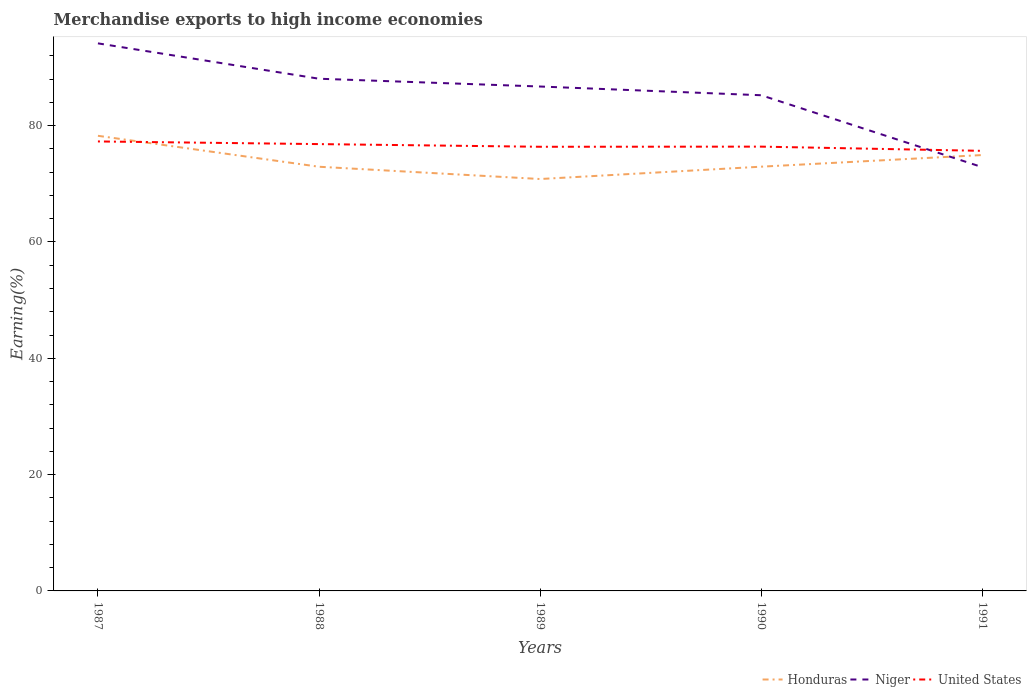Across all years, what is the maximum percentage of amount earned from merchandise exports in Honduras?
Keep it short and to the point. 70.82. What is the total percentage of amount earned from merchandise exports in Niger in the graph?
Make the answer very short. 1.5. What is the difference between the highest and the second highest percentage of amount earned from merchandise exports in Honduras?
Make the answer very short. 7.43. How many lines are there?
Provide a short and direct response. 3. Are the values on the major ticks of Y-axis written in scientific E-notation?
Provide a short and direct response. No. Does the graph contain any zero values?
Ensure brevity in your answer.  No. Does the graph contain grids?
Your answer should be compact. No. Where does the legend appear in the graph?
Keep it short and to the point. Bottom right. How many legend labels are there?
Ensure brevity in your answer.  3. What is the title of the graph?
Make the answer very short. Merchandise exports to high income economies. Does "Slovenia" appear as one of the legend labels in the graph?
Make the answer very short. No. What is the label or title of the X-axis?
Your answer should be very brief. Years. What is the label or title of the Y-axis?
Keep it short and to the point. Earning(%). What is the Earning(%) of Honduras in 1987?
Your answer should be compact. 78.25. What is the Earning(%) of Niger in 1987?
Provide a short and direct response. 94.15. What is the Earning(%) of United States in 1987?
Provide a succinct answer. 77.28. What is the Earning(%) of Honduras in 1988?
Your response must be concise. 72.93. What is the Earning(%) of Niger in 1988?
Give a very brief answer. 88.07. What is the Earning(%) in United States in 1988?
Provide a succinct answer. 76.83. What is the Earning(%) in Honduras in 1989?
Make the answer very short. 70.82. What is the Earning(%) of Niger in 1989?
Your answer should be compact. 86.73. What is the Earning(%) in United States in 1989?
Provide a short and direct response. 76.37. What is the Earning(%) of Honduras in 1990?
Provide a succinct answer. 72.94. What is the Earning(%) of Niger in 1990?
Provide a short and direct response. 85.23. What is the Earning(%) in United States in 1990?
Provide a short and direct response. 76.39. What is the Earning(%) of Honduras in 1991?
Your answer should be very brief. 74.95. What is the Earning(%) of Niger in 1991?
Provide a short and direct response. 72.86. What is the Earning(%) of United States in 1991?
Offer a terse response. 75.67. Across all years, what is the maximum Earning(%) of Honduras?
Keep it short and to the point. 78.25. Across all years, what is the maximum Earning(%) in Niger?
Provide a short and direct response. 94.15. Across all years, what is the maximum Earning(%) of United States?
Your answer should be compact. 77.28. Across all years, what is the minimum Earning(%) of Honduras?
Keep it short and to the point. 70.82. Across all years, what is the minimum Earning(%) in Niger?
Provide a short and direct response. 72.86. Across all years, what is the minimum Earning(%) in United States?
Your answer should be compact. 75.67. What is the total Earning(%) of Honduras in the graph?
Give a very brief answer. 369.9. What is the total Earning(%) of Niger in the graph?
Offer a terse response. 427.03. What is the total Earning(%) of United States in the graph?
Make the answer very short. 382.54. What is the difference between the Earning(%) in Honduras in 1987 and that in 1988?
Your response must be concise. 5.32. What is the difference between the Earning(%) in Niger in 1987 and that in 1988?
Offer a very short reply. 6.08. What is the difference between the Earning(%) of United States in 1987 and that in 1988?
Give a very brief answer. 0.46. What is the difference between the Earning(%) of Honduras in 1987 and that in 1989?
Provide a succinct answer. 7.43. What is the difference between the Earning(%) in Niger in 1987 and that in 1989?
Provide a short and direct response. 7.42. What is the difference between the Earning(%) of United States in 1987 and that in 1989?
Offer a terse response. 0.92. What is the difference between the Earning(%) in Honduras in 1987 and that in 1990?
Offer a terse response. 5.31. What is the difference between the Earning(%) of Niger in 1987 and that in 1990?
Ensure brevity in your answer.  8.92. What is the difference between the Earning(%) of United States in 1987 and that in 1990?
Offer a terse response. 0.89. What is the difference between the Earning(%) of Honduras in 1987 and that in 1991?
Provide a succinct answer. 3.31. What is the difference between the Earning(%) in Niger in 1987 and that in 1991?
Your response must be concise. 21.29. What is the difference between the Earning(%) in United States in 1987 and that in 1991?
Your answer should be compact. 1.62. What is the difference between the Earning(%) in Honduras in 1988 and that in 1989?
Offer a very short reply. 2.11. What is the difference between the Earning(%) of Niger in 1988 and that in 1989?
Offer a very short reply. 1.34. What is the difference between the Earning(%) of United States in 1988 and that in 1989?
Ensure brevity in your answer.  0.46. What is the difference between the Earning(%) of Honduras in 1988 and that in 1990?
Your response must be concise. -0.01. What is the difference between the Earning(%) of Niger in 1988 and that in 1990?
Offer a terse response. 2.84. What is the difference between the Earning(%) in United States in 1988 and that in 1990?
Keep it short and to the point. 0.43. What is the difference between the Earning(%) of Honduras in 1988 and that in 1991?
Give a very brief answer. -2.01. What is the difference between the Earning(%) in Niger in 1988 and that in 1991?
Offer a terse response. 15.2. What is the difference between the Earning(%) in United States in 1988 and that in 1991?
Your answer should be compact. 1.16. What is the difference between the Earning(%) in Honduras in 1989 and that in 1990?
Your answer should be very brief. -2.12. What is the difference between the Earning(%) of Niger in 1989 and that in 1990?
Make the answer very short. 1.5. What is the difference between the Earning(%) of United States in 1989 and that in 1990?
Offer a terse response. -0.02. What is the difference between the Earning(%) in Honduras in 1989 and that in 1991?
Provide a succinct answer. -4.12. What is the difference between the Earning(%) of Niger in 1989 and that in 1991?
Provide a succinct answer. 13.87. What is the difference between the Earning(%) in United States in 1989 and that in 1991?
Provide a succinct answer. 0.7. What is the difference between the Earning(%) of Honduras in 1990 and that in 1991?
Provide a short and direct response. -2. What is the difference between the Earning(%) of Niger in 1990 and that in 1991?
Provide a short and direct response. 12.37. What is the difference between the Earning(%) in United States in 1990 and that in 1991?
Make the answer very short. 0.72. What is the difference between the Earning(%) of Honduras in 1987 and the Earning(%) of Niger in 1988?
Your response must be concise. -9.81. What is the difference between the Earning(%) of Honduras in 1987 and the Earning(%) of United States in 1988?
Your answer should be very brief. 1.43. What is the difference between the Earning(%) of Niger in 1987 and the Earning(%) of United States in 1988?
Keep it short and to the point. 17.32. What is the difference between the Earning(%) of Honduras in 1987 and the Earning(%) of Niger in 1989?
Your response must be concise. -8.47. What is the difference between the Earning(%) of Honduras in 1987 and the Earning(%) of United States in 1989?
Offer a terse response. 1.89. What is the difference between the Earning(%) of Niger in 1987 and the Earning(%) of United States in 1989?
Provide a succinct answer. 17.78. What is the difference between the Earning(%) of Honduras in 1987 and the Earning(%) of Niger in 1990?
Keep it short and to the point. -6.97. What is the difference between the Earning(%) in Honduras in 1987 and the Earning(%) in United States in 1990?
Provide a succinct answer. 1.86. What is the difference between the Earning(%) of Niger in 1987 and the Earning(%) of United States in 1990?
Offer a terse response. 17.76. What is the difference between the Earning(%) in Honduras in 1987 and the Earning(%) in Niger in 1991?
Your answer should be very brief. 5.39. What is the difference between the Earning(%) of Honduras in 1987 and the Earning(%) of United States in 1991?
Your response must be concise. 2.59. What is the difference between the Earning(%) of Niger in 1987 and the Earning(%) of United States in 1991?
Provide a short and direct response. 18.48. What is the difference between the Earning(%) of Honduras in 1988 and the Earning(%) of Niger in 1989?
Offer a terse response. -13.8. What is the difference between the Earning(%) in Honduras in 1988 and the Earning(%) in United States in 1989?
Offer a terse response. -3.43. What is the difference between the Earning(%) in Niger in 1988 and the Earning(%) in United States in 1989?
Make the answer very short. 11.7. What is the difference between the Earning(%) in Honduras in 1988 and the Earning(%) in Niger in 1990?
Offer a very short reply. -12.3. What is the difference between the Earning(%) in Honduras in 1988 and the Earning(%) in United States in 1990?
Provide a short and direct response. -3.46. What is the difference between the Earning(%) in Niger in 1988 and the Earning(%) in United States in 1990?
Your answer should be compact. 11.67. What is the difference between the Earning(%) of Honduras in 1988 and the Earning(%) of Niger in 1991?
Offer a very short reply. 0.07. What is the difference between the Earning(%) in Honduras in 1988 and the Earning(%) in United States in 1991?
Give a very brief answer. -2.73. What is the difference between the Earning(%) in Niger in 1988 and the Earning(%) in United States in 1991?
Offer a terse response. 12.4. What is the difference between the Earning(%) in Honduras in 1989 and the Earning(%) in Niger in 1990?
Your answer should be very brief. -14.4. What is the difference between the Earning(%) of Honduras in 1989 and the Earning(%) of United States in 1990?
Provide a short and direct response. -5.57. What is the difference between the Earning(%) of Niger in 1989 and the Earning(%) of United States in 1990?
Your answer should be compact. 10.34. What is the difference between the Earning(%) in Honduras in 1989 and the Earning(%) in Niger in 1991?
Ensure brevity in your answer.  -2.04. What is the difference between the Earning(%) in Honduras in 1989 and the Earning(%) in United States in 1991?
Make the answer very short. -4.84. What is the difference between the Earning(%) of Niger in 1989 and the Earning(%) of United States in 1991?
Offer a terse response. 11.06. What is the difference between the Earning(%) in Honduras in 1990 and the Earning(%) in Niger in 1991?
Offer a terse response. 0.08. What is the difference between the Earning(%) in Honduras in 1990 and the Earning(%) in United States in 1991?
Keep it short and to the point. -2.72. What is the difference between the Earning(%) in Niger in 1990 and the Earning(%) in United States in 1991?
Ensure brevity in your answer.  9.56. What is the average Earning(%) in Honduras per year?
Give a very brief answer. 73.98. What is the average Earning(%) in Niger per year?
Provide a succinct answer. 85.41. What is the average Earning(%) in United States per year?
Provide a succinct answer. 76.51. In the year 1987, what is the difference between the Earning(%) of Honduras and Earning(%) of Niger?
Provide a short and direct response. -15.89. In the year 1987, what is the difference between the Earning(%) of Honduras and Earning(%) of United States?
Your response must be concise. 0.97. In the year 1987, what is the difference between the Earning(%) in Niger and Earning(%) in United States?
Ensure brevity in your answer.  16.86. In the year 1988, what is the difference between the Earning(%) of Honduras and Earning(%) of Niger?
Keep it short and to the point. -15.13. In the year 1988, what is the difference between the Earning(%) of Honduras and Earning(%) of United States?
Ensure brevity in your answer.  -3.89. In the year 1988, what is the difference between the Earning(%) in Niger and Earning(%) in United States?
Make the answer very short. 11.24. In the year 1989, what is the difference between the Earning(%) of Honduras and Earning(%) of Niger?
Make the answer very short. -15.9. In the year 1989, what is the difference between the Earning(%) of Honduras and Earning(%) of United States?
Offer a terse response. -5.54. In the year 1989, what is the difference between the Earning(%) in Niger and Earning(%) in United States?
Give a very brief answer. 10.36. In the year 1990, what is the difference between the Earning(%) in Honduras and Earning(%) in Niger?
Ensure brevity in your answer.  -12.28. In the year 1990, what is the difference between the Earning(%) in Honduras and Earning(%) in United States?
Provide a short and direct response. -3.45. In the year 1990, what is the difference between the Earning(%) in Niger and Earning(%) in United States?
Make the answer very short. 8.84. In the year 1991, what is the difference between the Earning(%) of Honduras and Earning(%) of Niger?
Your answer should be compact. 2.08. In the year 1991, what is the difference between the Earning(%) of Honduras and Earning(%) of United States?
Offer a very short reply. -0.72. In the year 1991, what is the difference between the Earning(%) in Niger and Earning(%) in United States?
Your answer should be compact. -2.81. What is the ratio of the Earning(%) of Honduras in 1987 to that in 1988?
Offer a very short reply. 1.07. What is the ratio of the Earning(%) in Niger in 1987 to that in 1988?
Your answer should be very brief. 1.07. What is the ratio of the Earning(%) of United States in 1987 to that in 1988?
Offer a very short reply. 1.01. What is the ratio of the Earning(%) of Honduras in 1987 to that in 1989?
Your response must be concise. 1.1. What is the ratio of the Earning(%) of Niger in 1987 to that in 1989?
Your answer should be very brief. 1.09. What is the ratio of the Earning(%) of United States in 1987 to that in 1989?
Ensure brevity in your answer.  1.01. What is the ratio of the Earning(%) of Honduras in 1987 to that in 1990?
Your response must be concise. 1.07. What is the ratio of the Earning(%) of Niger in 1987 to that in 1990?
Your answer should be very brief. 1.1. What is the ratio of the Earning(%) of United States in 1987 to that in 1990?
Provide a succinct answer. 1.01. What is the ratio of the Earning(%) in Honduras in 1987 to that in 1991?
Offer a terse response. 1.04. What is the ratio of the Earning(%) of Niger in 1987 to that in 1991?
Ensure brevity in your answer.  1.29. What is the ratio of the Earning(%) of United States in 1987 to that in 1991?
Offer a very short reply. 1.02. What is the ratio of the Earning(%) of Honduras in 1988 to that in 1989?
Keep it short and to the point. 1.03. What is the ratio of the Earning(%) in Niger in 1988 to that in 1989?
Your answer should be very brief. 1.02. What is the ratio of the Earning(%) of Honduras in 1988 to that in 1990?
Your answer should be compact. 1. What is the ratio of the Earning(%) in Niger in 1988 to that in 1990?
Ensure brevity in your answer.  1.03. What is the ratio of the Earning(%) of United States in 1988 to that in 1990?
Keep it short and to the point. 1.01. What is the ratio of the Earning(%) in Honduras in 1988 to that in 1991?
Your answer should be compact. 0.97. What is the ratio of the Earning(%) of Niger in 1988 to that in 1991?
Give a very brief answer. 1.21. What is the ratio of the Earning(%) of United States in 1988 to that in 1991?
Provide a succinct answer. 1.02. What is the ratio of the Earning(%) of Honduras in 1989 to that in 1990?
Make the answer very short. 0.97. What is the ratio of the Earning(%) in Niger in 1989 to that in 1990?
Your response must be concise. 1.02. What is the ratio of the Earning(%) in Honduras in 1989 to that in 1991?
Your answer should be compact. 0.94. What is the ratio of the Earning(%) of Niger in 1989 to that in 1991?
Ensure brevity in your answer.  1.19. What is the ratio of the Earning(%) in United States in 1989 to that in 1991?
Ensure brevity in your answer.  1.01. What is the ratio of the Earning(%) in Honduras in 1990 to that in 1991?
Offer a terse response. 0.97. What is the ratio of the Earning(%) in Niger in 1990 to that in 1991?
Offer a very short reply. 1.17. What is the ratio of the Earning(%) of United States in 1990 to that in 1991?
Make the answer very short. 1.01. What is the difference between the highest and the second highest Earning(%) of Honduras?
Keep it short and to the point. 3.31. What is the difference between the highest and the second highest Earning(%) of Niger?
Your response must be concise. 6.08. What is the difference between the highest and the second highest Earning(%) in United States?
Ensure brevity in your answer.  0.46. What is the difference between the highest and the lowest Earning(%) in Honduras?
Make the answer very short. 7.43. What is the difference between the highest and the lowest Earning(%) in Niger?
Your answer should be very brief. 21.29. What is the difference between the highest and the lowest Earning(%) of United States?
Your answer should be compact. 1.62. 